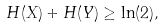<formula> <loc_0><loc_0><loc_500><loc_500>H ( X ) + H ( Y ) \geq \ln ( 2 ) ,</formula> 